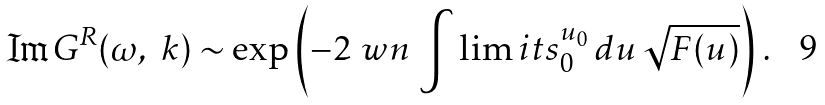<formula> <loc_0><loc_0><loc_500><loc_500>\Im G ^ { R } ( \omega , \ k ) \sim \exp \left ( - 2 \ w n \, \int \lim i t s _ { 0 } ^ { u _ { 0 } } \, d u \, \sqrt { F ( u ) } \right ) \, .</formula> 